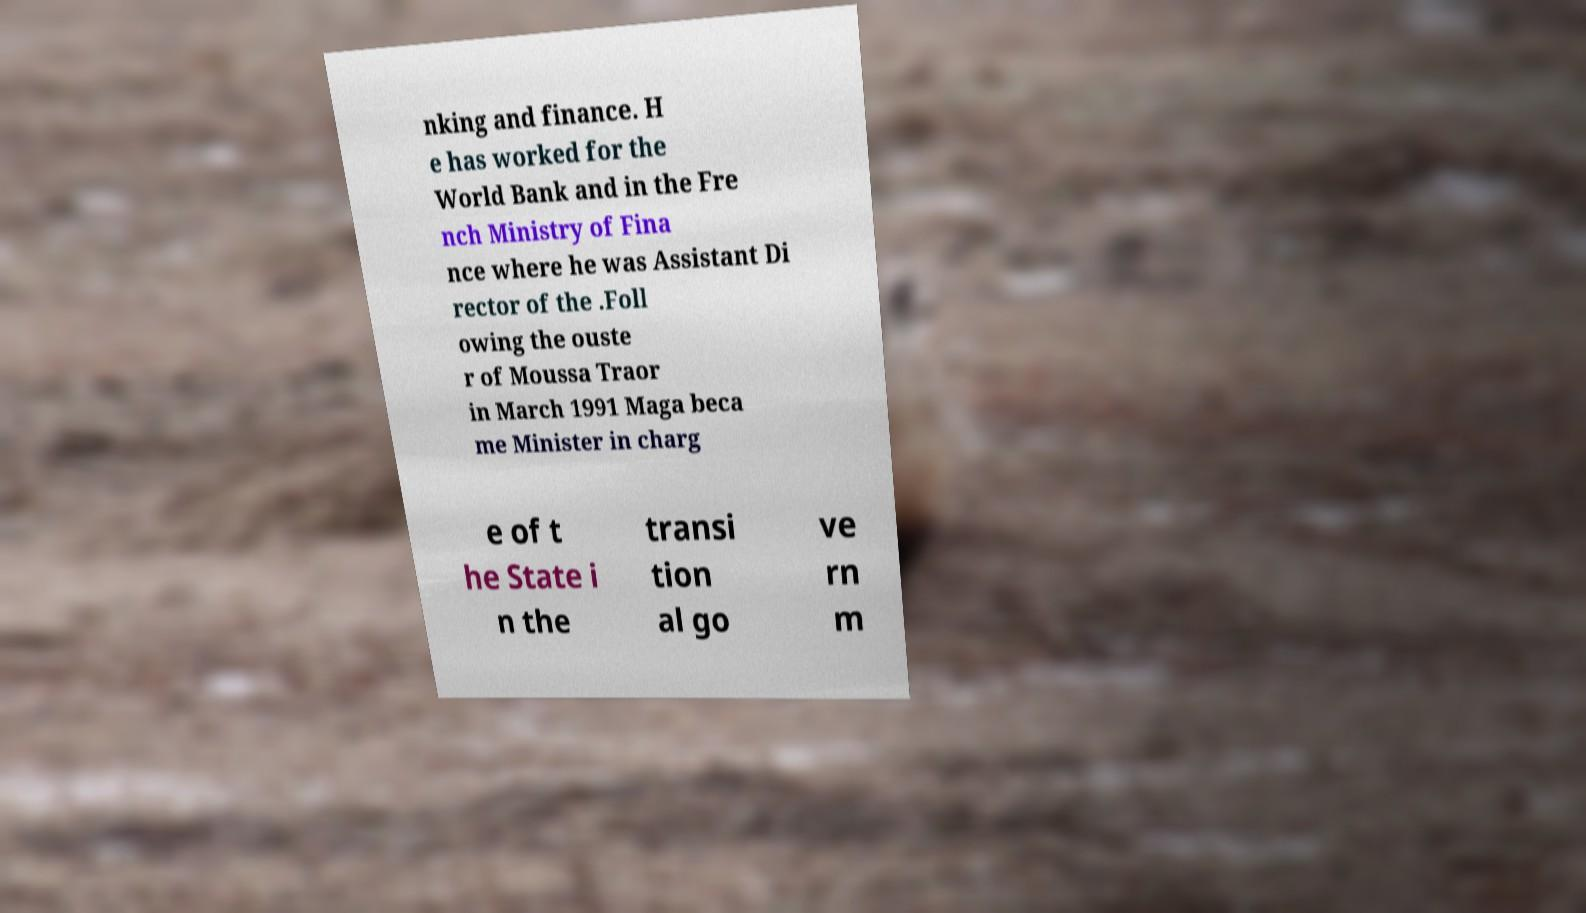There's text embedded in this image that I need extracted. Can you transcribe it verbatim? nking and finance. H e has worked for the World Bank and in the Fre nch Ministry of Fina nce where he was Assistant Di rector of the .Foll owing the ouste r of Moussa Traor in March 1991 Maga beca me Minister in charg e of t he State i n the transi tion al go ve rn m 